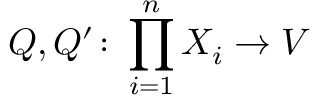Convert formula to latex. <formula><loc_0><loc_0><loc_500><loc_500>Q , Q ^ { \prime } \colon \prod _ { i = 1 } ^ { n } X _ { i } \to V</formula> 